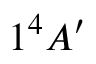Convert formula to latex. <formula><loc_0><loc_0><loc_500><loc_500>1 ^ { 4 } A ^ { \prime }</formula> 